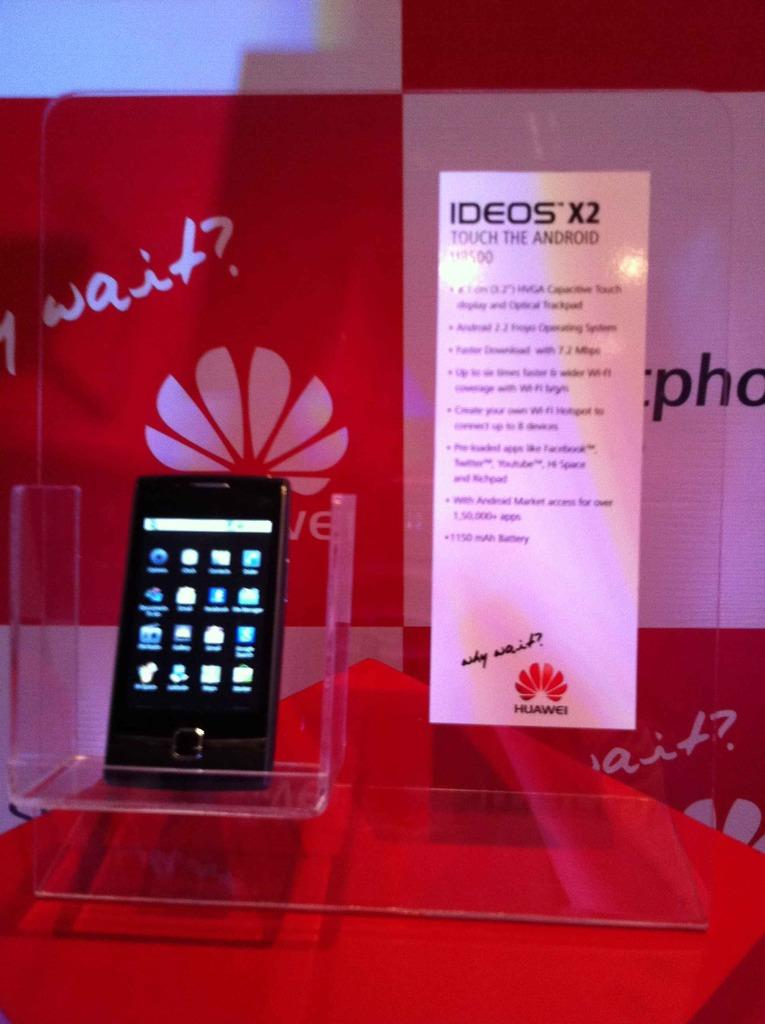<image>
Describe the image concisely. an advertisement for the ideos x2 phone by huawei 